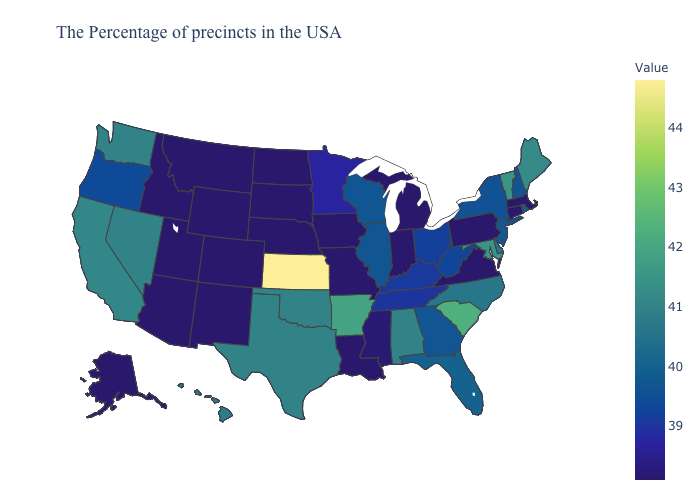Does West Virginia have a higher value than Alabama?
Answer briefly. No. Does the map have missing data?
Write a very short answer. No. Does Oregon have the lowest value in the USA?
Keep it brief. No. Which states have the lowest value in the MidWest?
Concise answer only. Michigan, Indiana, Missouri, Iowa, Nebraska, South Dakota, North Dakota. Does New Hampshire have the highest value in the Northeast?
Short answer required. No. 